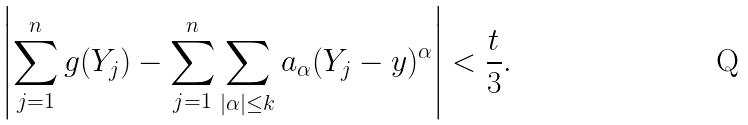<formula> <loc_0><loc_0><loc_500><loc_500>\left | \sum _ { j = 1 } ^ { n } g ( Y _ { j } ) - \sum _ { j = 1 } ^ { n } \sum _ { | \alpha | \leq k } a _ { \alpha } ( Y _ { j } - y ) ^ { \alpha } \right | < \frac { t } { 3 } .</formula> 